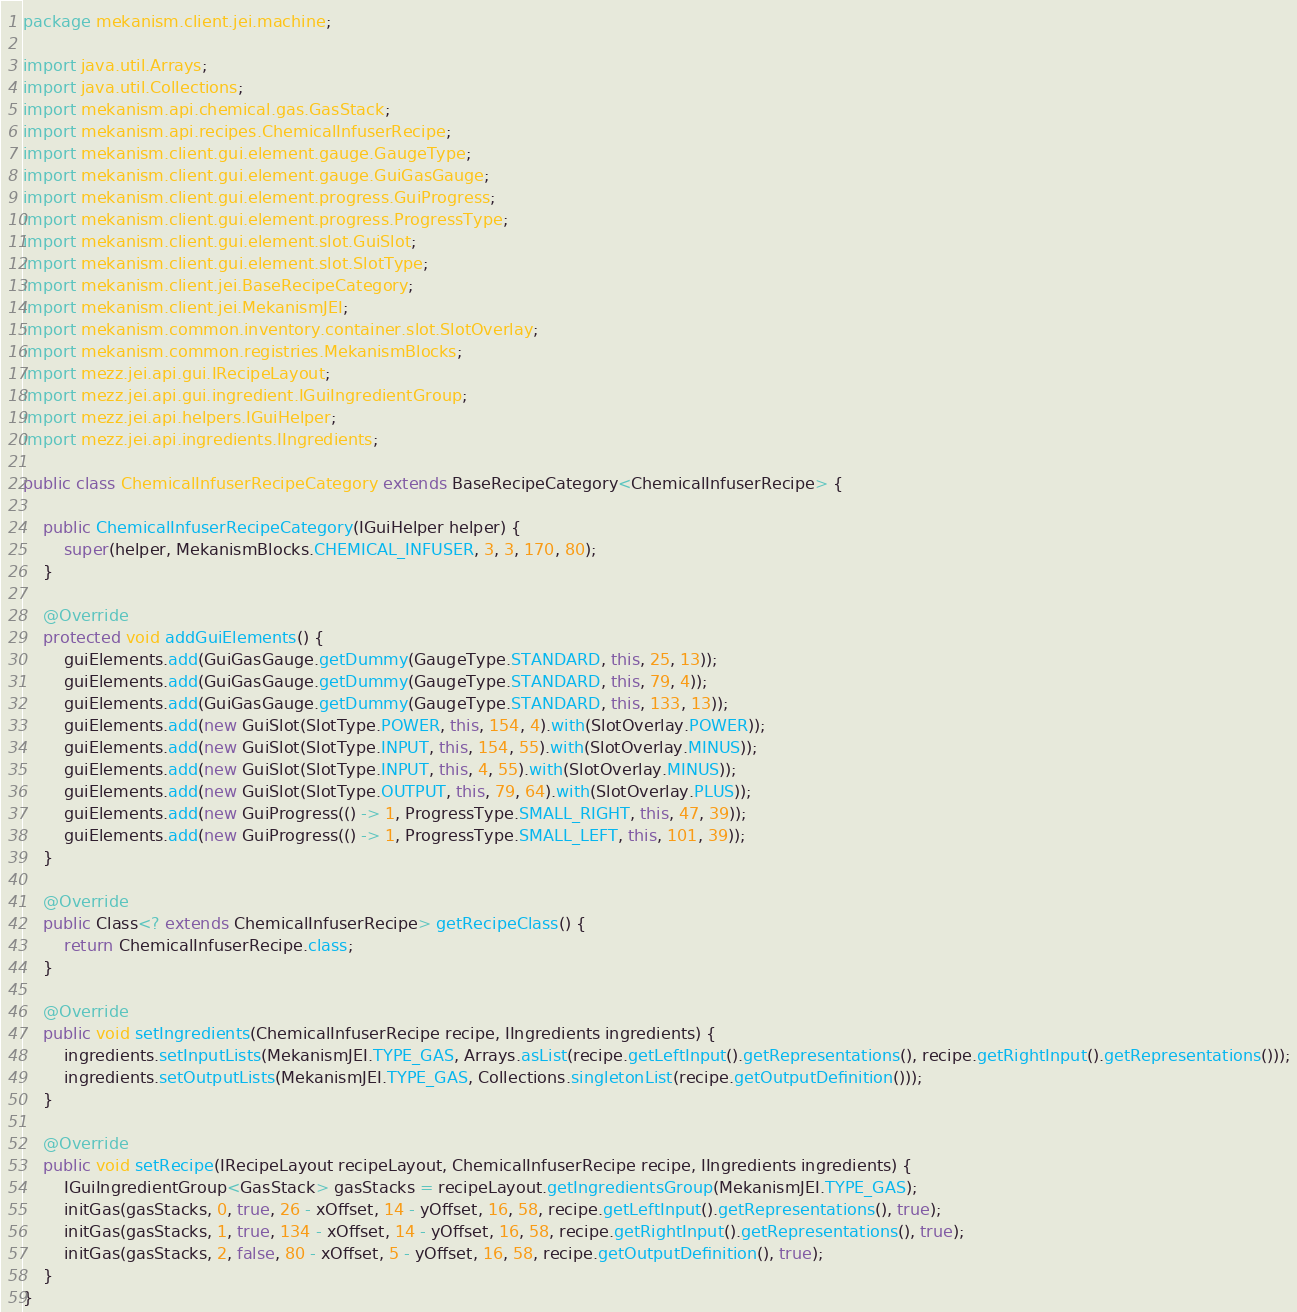Convert code to text. <code><loc_0><loc_0><loc_500><loc_500><_Java_>package mekanism.client.jei.machine;

import java.util.Arrays;
import java.util.Collections;
import mekanism.api.chemical.gas.GasStack;
import mekanism.api.recipes.ChemicalInfuserRecipe;
import mekanism.client.gui.element.gauge.GaugeType;
import mekanism.client.gui.element.gauge.GuiGasGauge;
import mekanism.client.gui.element.progress.GuiProgress;
import mekanism.client.gui.element.progress.ProgressType;
import mekanism.client.gui.element.slot.GuiSlot;
import mekanism.client.gui.element.slot.SlotType;
import mekanism.client.jei.BaseRecipeCategory;
import mekanism.client.jei.MekanismJEI;
import mekanism.common.inventory.container.slot.SlotOverlay;
import mekanism.common.registries.MekanismBlocks;
import mezz.jei.api.gui.IRecipeLayout;
import mezz.jei.api.gui.ingredient.IGuiIngredientGroup;
import mezz.jei.api.helpers.IGuiHelper;
import mezz.jei.api.ingredients.IIngredients;

public class ChemicalInfuserRecipeCategory extends BaseRecipeCategory<ChemicalInfuserRecipe> {

    public ChemicalInfuserRecipeCategory(IGuiHelper helper) {
        super(helper, MekanismBlocks.CHEMICAL_INFUSER, 3, 3, 170, 80);
    }

    @Override
    protected void addGuiElements() {
        guiElements.add(GuiGasGauge.getDummy(GaugeType.STANDARD, this, 25, 13));
        guiElements.add(GuiGasGauge.getDummy(GaugeType.STANDARD, this, 79, 4));
        guiElements.add(GuiGasGauge.getDummy(GaugeType.STANDARD, this, 133, 13));
        guiElements.add(new GuiSlot(SlotType.POWER, this, 154, 4).with(SlotOverlay.POWER));
        guiElements.add(new GuiSlot(SlotType.INPUT, this, 154, 55).with(SlotOverlay.MINUS));
        guiElements.add(new GuiSlot(SlotType.INPUT, this, 4, 55).with(SlotOverlay.MINUS));
        guiElements.add(new GuiSlot(SlotType.OUTPUT, this, 79, 64).with(SlotOverlay.PLUS));
        guiElements.add(new GuiProgress(() -> 1, ProgressType.SMALL_RIGHT, this, 47, 39));
        guiElements.add(new GuiProgress(() -> 1, ProgressType.SMALL_LEFT, this, 101, 39));
    }

    @Override
    public Class<? extends ChemicalInfuserRecipe> getRecipeClass() {
        return ChemicalInfuserRecipe.class;
    }

    @Override
    public void setIngredients(ChemicalInfuserRecipe recipe, IIngredients ingredients) {
        ingredients.setInputLists(MekanismJEI.TYPE_GAS, Arrays.asList(recipe.getLeftInput().getRepresentations(), recipe.getRightInput().getRepresentations()));
        ingredients.setOutputLists(MekanismJEI.TYPE_GAS, Collections.singletonList(recipe.getOutputDefinition()));
    }

    @Override
    public void setRecipe(IRecipeLayout recipeLayout, ChemicalInfuserRecipe recipe, IIngredients ingredients) {
        IGuiIngredientGroup<GasStack> gasStacks = recipeLayout.getIngredientsGroup(MekanismJEI.TYPE_GAS);
        initGas(gasStacks, 0, true, 26 - xOffset, 14 - yOffset, 16, 58, recipe.getLeftInput().getRepresentations(), true);
        initGas(gasStacks, 1, true, 134 - xOffset, 14 - yOffset, 16, 58, recipe.getRightInput().getRepresentations(), true);
        initGas(gasStacks, 2, false, 80 - xOffset, 5 - yOffset, 16, 58, recipe.getOutputDefinition(), true);
    }
}</code> 